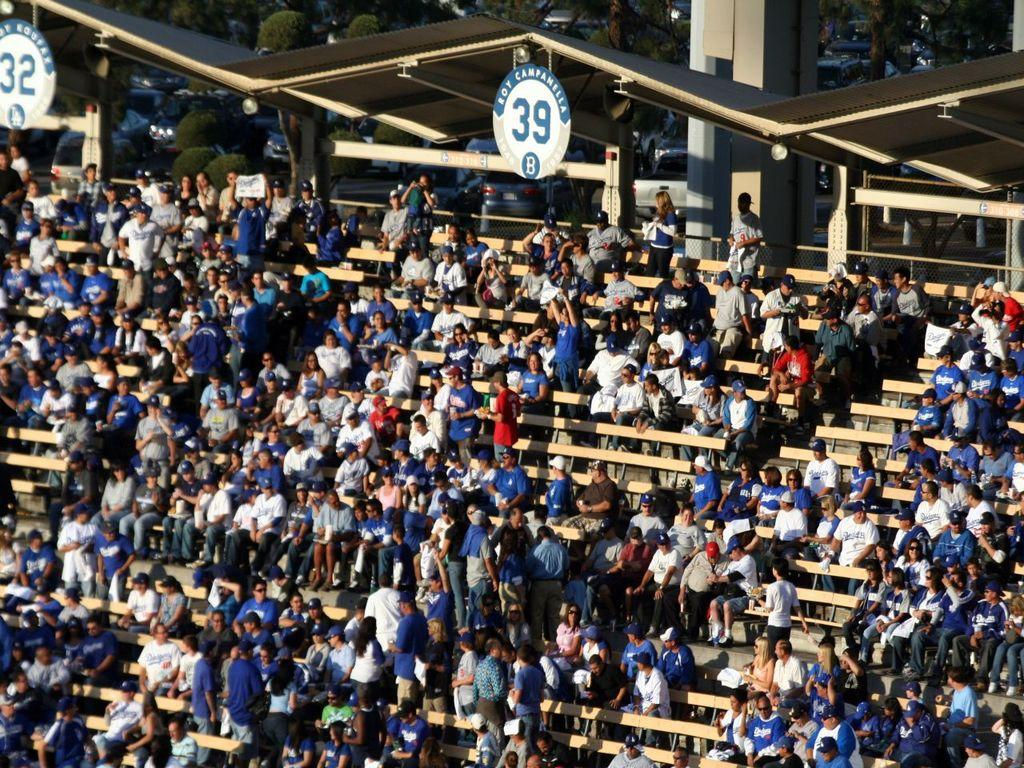What are the people in the image doing? There are people sitting and standing in the image. Where is the location of the image? The location is a stadium. What objects can be seen in the image besides people? Boards and trees are visible in the image. What can be seen in the background of the image? Cars are parked in the background of the image. What type of hat is the oatmeal wearing in the image? There is no oatmeal or hat present in the image. 